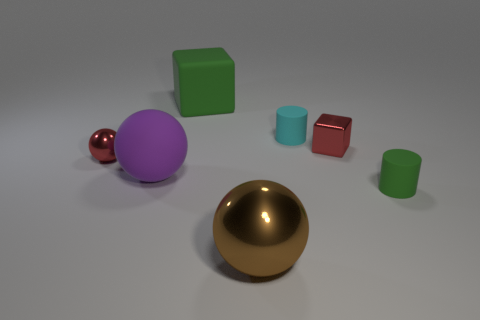How many things are rubber cubes or matte cubes that are behind the red ball?
Your answer should be compact. 1. Is the material of the cyan thing the same as the small ball?
Provide a succinct answer. No. What number of other objects are there of the same material as the cyan cylinder?
Offer a very short reply. 3. Are there more blue metallic spheres than large matte blocks?
Your response must be concise. No. There is a rubber thing that is on the right side of the cyan cylinder; is it the same shape as the large green rubber object?
Your response must be concise. No. Are there fewer brown blocks than small red things?
Your answer should be compact. Yes. There is a cube that is the same size as the brown shiny ball; what material is it?
Keep it short and to the point. Rubber. There is a big rubber cube; is it the same color as the shiny thing that is in front of the purple matte object?
Give a very brief answer. No. Is the number of big brown shiny spheres that are behind the small cyan matte object less than the number of red objects?
Make the answer very short. Yes. How many cylinders are there?
Make the answer very short. 2. 